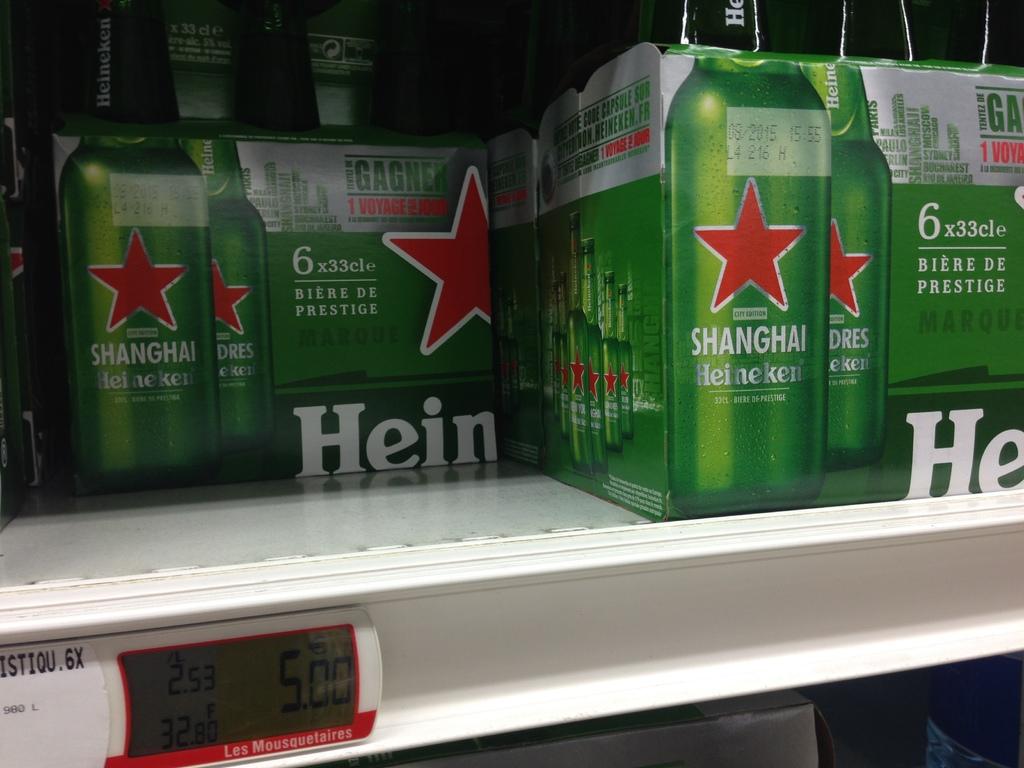Is this the heineken?
Give a very brief answer. Yes. How many bottles are in each pack of beer?
Offer a very short reply. 6. 